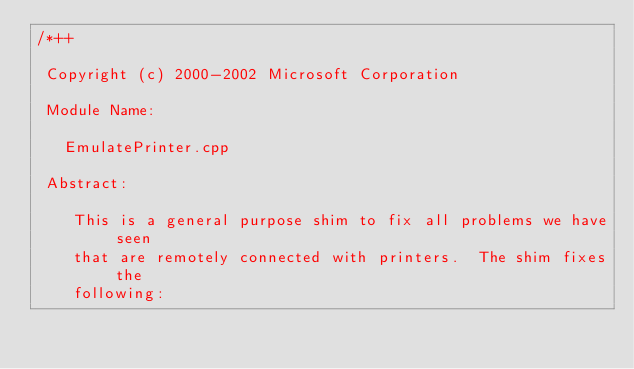Convert code to text. <code><loc_0><loc_0><loc_500><loc_500><_C++_>/*++

 Copyright (c) 2000-2002 Microsoft Corporation

 Module Name:

   EmulatePrinter.cpp

 Abstract:

    This is a general purpose shim to fix all problems we have seen
    that are remotely connected with printers.  The shim fixes the
    following:
</code> 